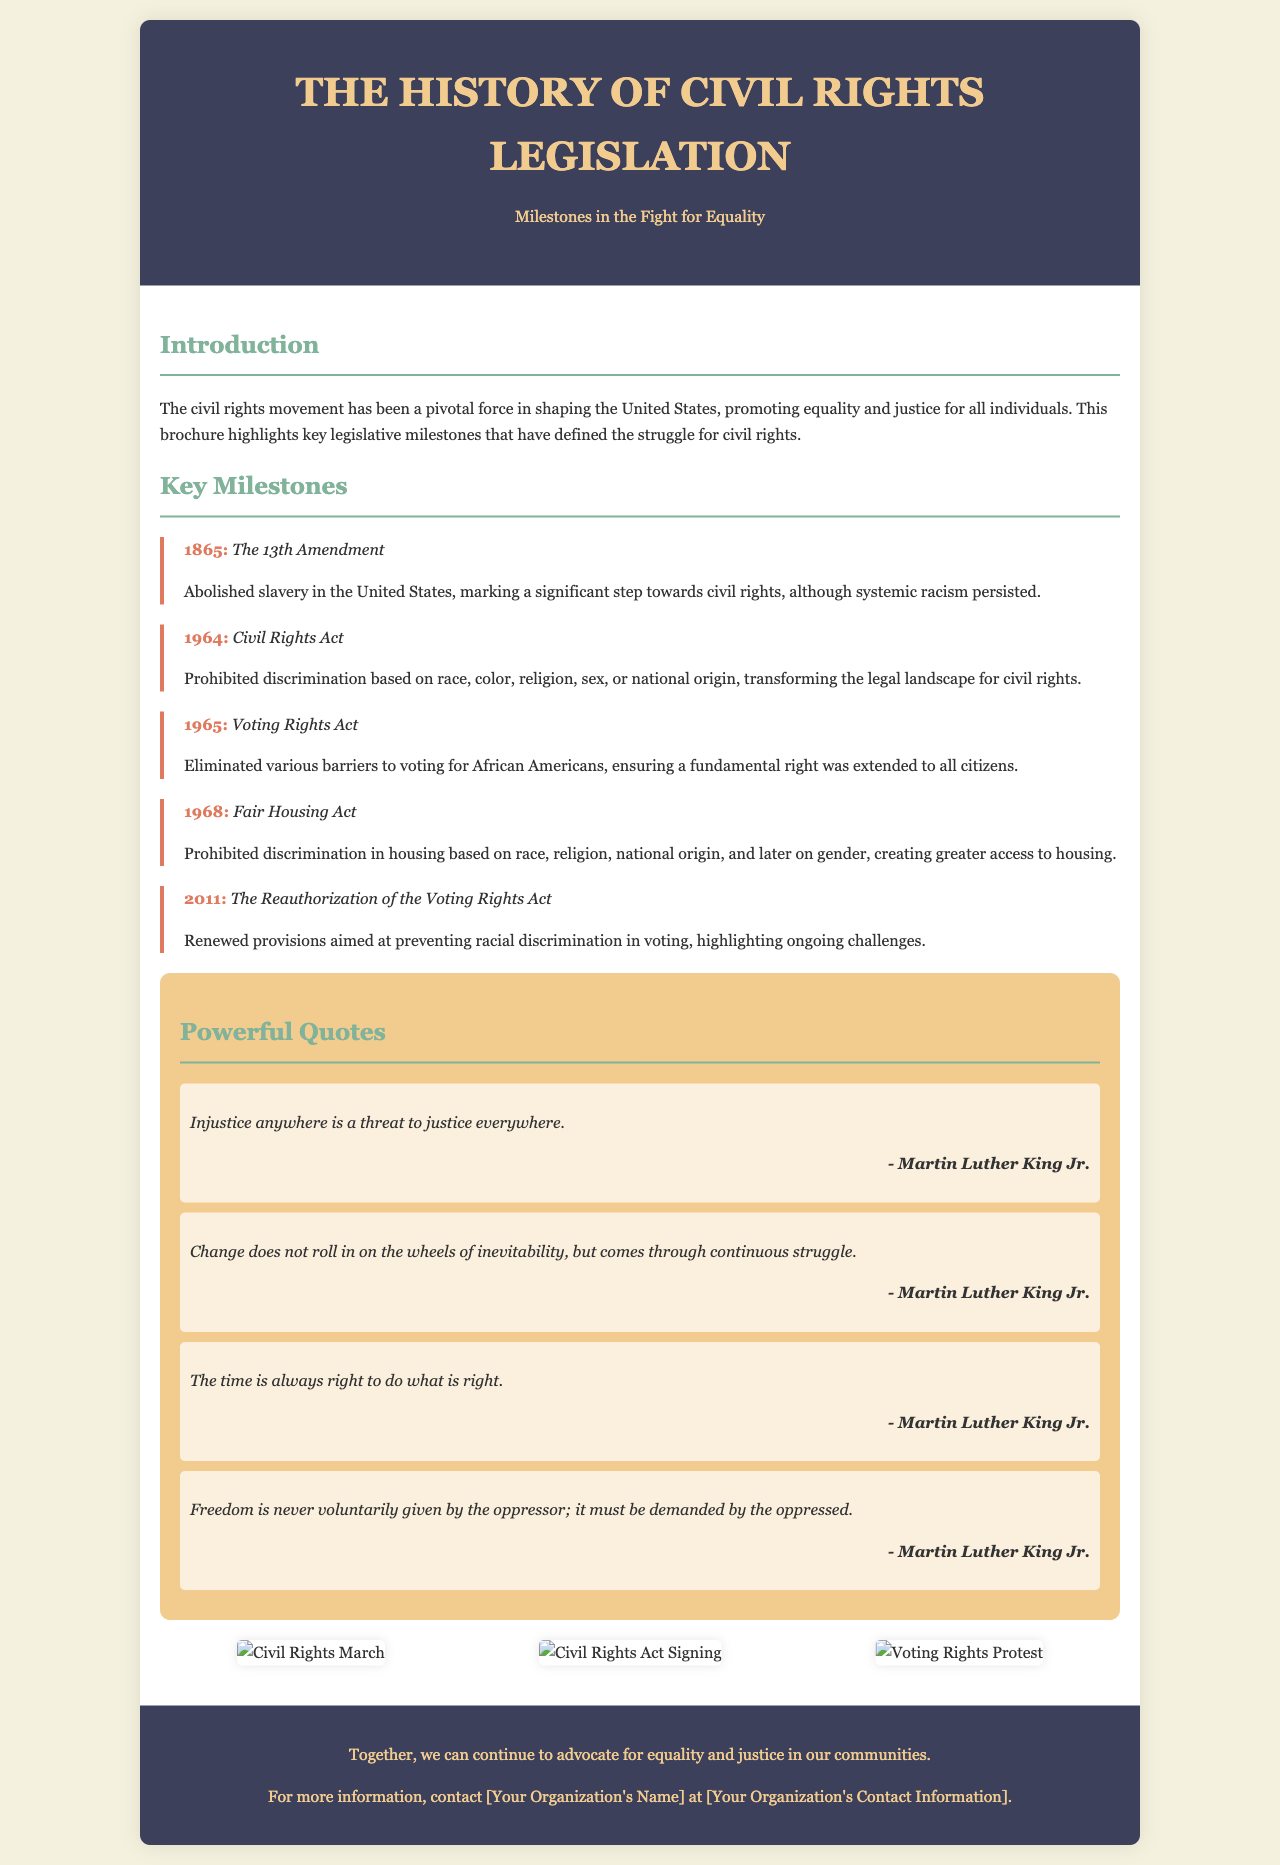What year was the 13th Amendment enacted? The document states that the 13th Amendment was enacted in the year 1865.
Answer: 1865 What does the Civil Rights Act of 1964 prohibit? The document indicates that the Civil Rights Act prohibits discrimination based on race, color, religion, sex, or national origin.
Answer: Discrimination Which milestone eliminated barriers to voting for African Americans? The document mentions that the Voting Rights Act of 1965 eliminated various barriers to voting for African Americans.
Answer: Voting Rights Act What significant action took place in 2011 related to voting rights? The document notes that in 2011, the Voting Rights Act was reauthorized to prevent racial discrimination in voting.
Answer: Reauthorization Who is quoted saying, "Injustice anywhere is a threat to justice everywhere"? The document attributes this quote to Martin Luther King Jr.
Answer: Martin Luther King Jr How many key milestones are listed in the document? By counting the milestones presented in the document, there are five key milestones listed.
Answer: Five What color is the header background? The brochure specifies that the header background is colored #3d405b.
Answer: #3d405b What does the closing statement of the brochure encourage? The closing statement encourages continuing advocacy for equality and justice in communities.
Answer: Advocacy for equality and justice 